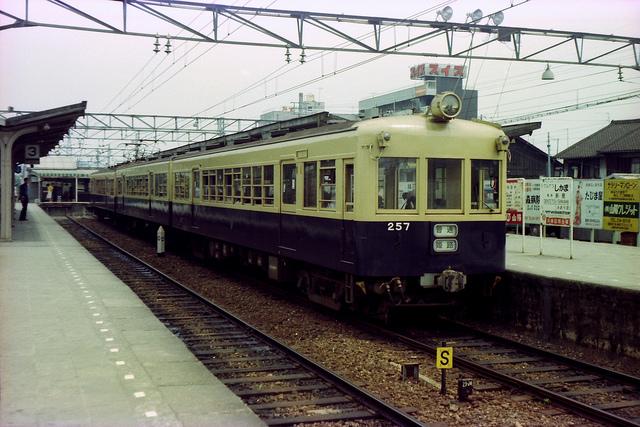How many people are on the platform?
Answer briefly. 1. Who is waiting for the train?
Be succinct. Man. What number is the train?
Concise answer only. 257. What color is the train?
Answer briefly. White and blue. What train is this?
Quick response, please. 257. 